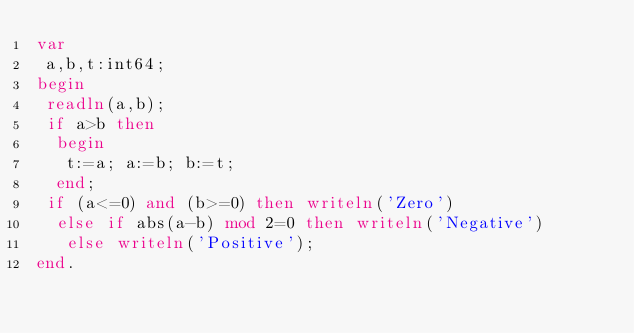<code> <loc_0><loc_0><loc_500><loc_500><_Pascal_>var
 a,b,t:int64;
begin
 readln(a,b);
 if a>b then
  begin
   t:=a; a:=b; b:=t;
  end;
 if (a<=0) and (b>=0) then writeln('Zero')
  else if abs(a-b) mod 2=0 then writeln('Negative')
   else writeln('Positive');
end.</code> 